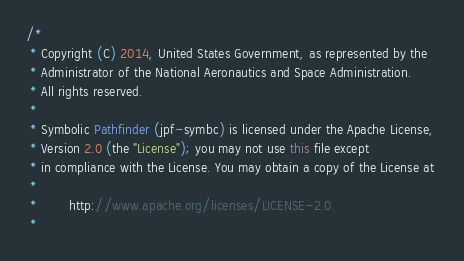<code> <loc_0><loc_0><loc_500><loc_500><_Java_>/*
 * Copyright (C) 2014, United States Government, as represented by the
 * Administrator of the National Aeronautics and Space Administration.
 * All rights reserved.
 *
 * Symbolic Pathfinder (jpf-symbc) is licensed under the Apache License, 
 * Version 2.0 (the "License"); you may not use this file except
 * in compliance with the License. You may obtain a copy of the License at
 * 
 *        http://www.apache.org/licenses/LICENSE-2.0. 
 *</code> 